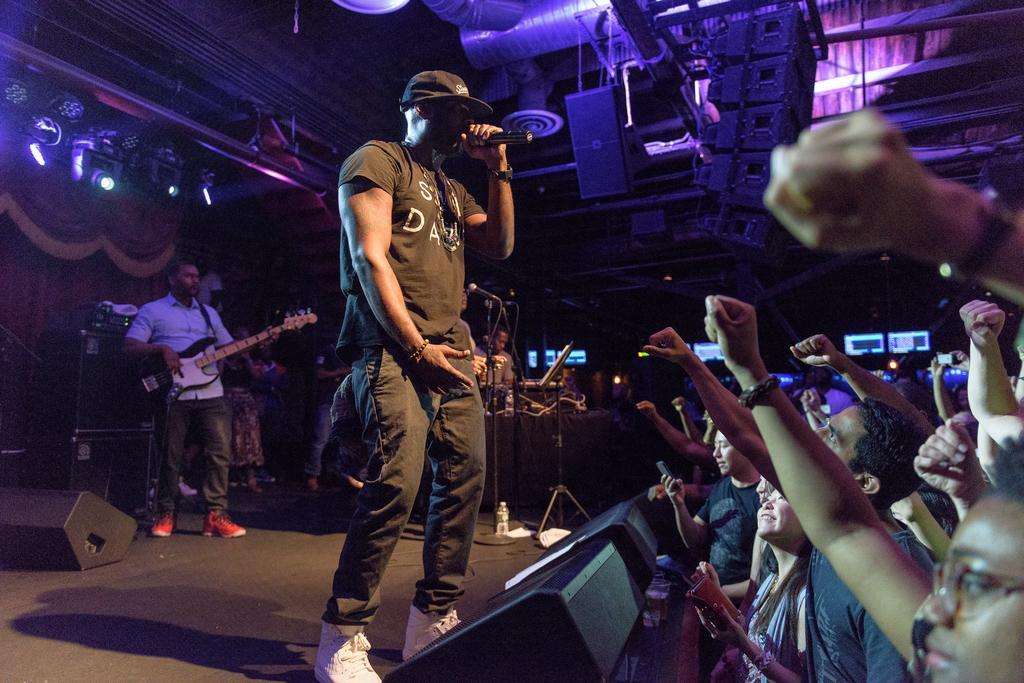Describe this image in one or two sentences. As we can see in the image there are few people here and there. The man who is standing here is singing song on mic and this man is holding guitar. 